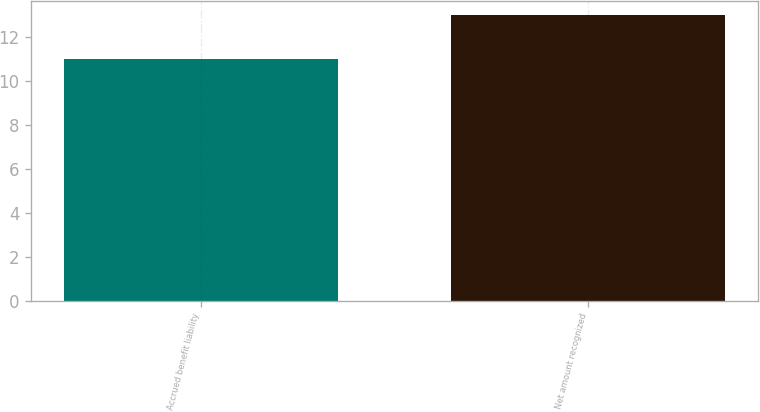Convert chart. <chart><loc_0><loc_0><loc_500><loc_500><bar_chart><fcel>Accrued benefit liability<fcel>Net amount recognized<nl><fcel>11<fcel>13<nl></chart> 